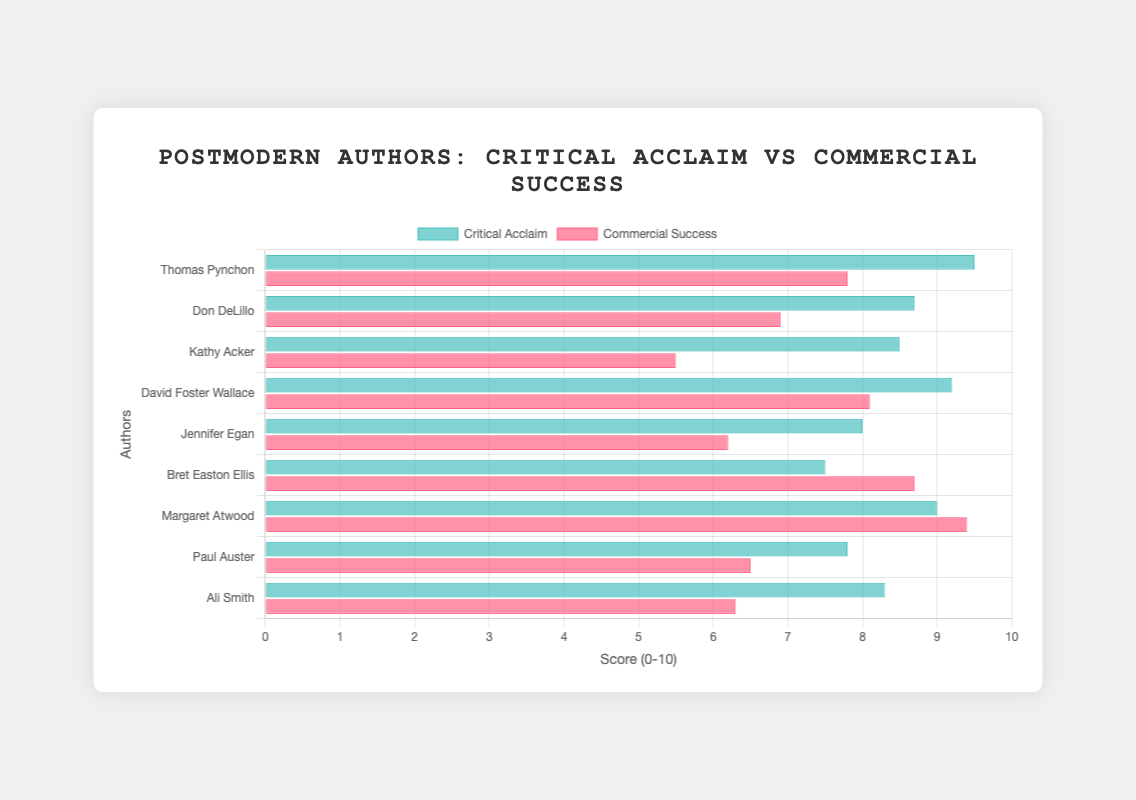Which author has the highest critical acclaim score? The figure shows bars representing the critical acclaim score for each author. The tallest bar for critical acclaim belongs to Thomas Pynchon.
Answer: Thomas Pynchon Which female author has the greatest commercial success? The figure shows bars representing the commercial success of female authors. Margaret Atwood has the highest commercial success score among the female authors.
Answer: Margaret Atwood What is the difference between the commercial success and critical acclaim for Bret Easton Ellis? For Bret Easton Ellis, the critical acclaim score is 7.5 and the commercial success score is 8.7. The difference is calculated as 8.7 - 7.5.
Answer: 1.2 Which author has the closest balance between critical acclaim and commercial success? By comparing the lengths of the bars for critical acclaim and commercial success for each author, Margaret Atwood has the closest balance, with scores very close to each other.
Answer: Margaret Atwood How much higher is Thomas Pynchon's critical acclaim compared to Don DeLillo's? Thomas Pynchon's critical acclaim is 9.5 and Don DeLillo's is 8.7. The difference is calculated as 9.5 - 8.7.
Answer: 0.8 What is the average commercial success score of the male authors? Sum the commercial success scores of male authors (7.8, 6.9, 8.1, 8.7, 6.5) and divide by the number of male authors (5). (7.8 + 6.9 + 8.1 + 8.7 + 6.5) / 5 = 38 / 5.
Answer: 7.6 Which author has the largest disparity between critical acclaim and commercial success? Compare the differences between critical acclaim and commercial success for each author. Kathy Acker has the largest disparity, with a critical acclaim of 8.5 and a commercial success of 5.5, a difference of 3.
Answer: Kathy Acker Which author's bars have the most relative visual prominence in critical acclaim? By observing the chart, Thomas Pynchon's bar for critical acclaim is significantly taller than his commercial success bar, indicating the highest visual prominence.
Answer: Thomas Pynchon 